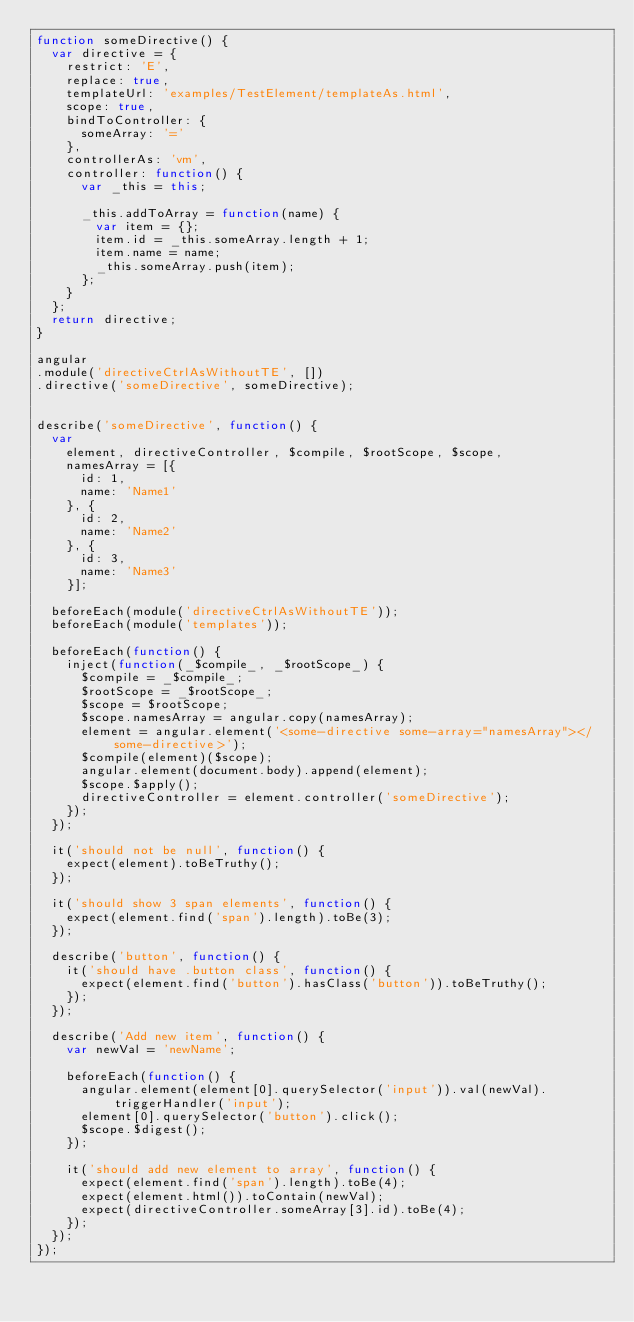Convert code to text. <code><loc_0><loc_0><loc_500><loc_500><_JavaScript_>function someDirective() {
  var directive = {
    restrict: 'E',
    replace: true,
    templateUrl: 'examples/TestElement/templateAs.html',
    scope: true,
    bindToController: {
      someArray: '='
    },
    controllerAs: 'vm',
    controller: function() {
      var _this = this;

      _this.addToArray = function(name) {
        var item = {};
        item.id = _this.someArray.length + 1;
        item.name = name;
        _this.someArray.push(item);
      };
    }
  };
  return directive;
}

angular
.module('directiveCtrlAsWithoutTE', [])
.directive('someDirective', someDirective);


describe('someDirective', function() {
  var
    element, directiveController, $compile, $rootScope, $scope,
    namesArray = [{
      id: 1,
      name: 'Name1'
    }, {
      id: 2,
      name: 'Name2'
    }, {
      id: 3,
      name: 'Name3'
    }];

  beforeEach(module('directiveCtrlAsWithoutTE'));
  beforeEach(module('templates'));

  beforeEach(function() {
    inject(function(_$compile_, _$rootScope_) {
      $compile = _$compile_;
      $rootScope = _$rootScope_;
      $scope = $rootScope;
      $scope.namesArray = angular.copy(namesArray);
      element = angular.element('<some-directive some-array="namesArray"></some-directive>');
      $compile(element)($scope);
      angular.element(document.body).append(element);
      $scope.$apply();
      directiveController = element.controller('someDirective');
    });
  });

  it('should not be null', function() {
    expect(element).toBeTruthy();
  });

  it('should show 3 span elements', function() {
    expect(element.find('span').length).toBe(3);
  });

  describe('button', function() {
    it('should have .button class', function() {
      expect(element.find('button').hasClass('button')).toBeTruthy();
    });
  });

  describe('Add new item', function() {
    var newVal = 'newName';

    beforeEach(function() {
      angular.element(element[0].querySelector('input')).val(newVal).triggerHandler('input');
      element[0].querySelector('button').click();
      $scope.$digest();
    });

    it('should add new element to array', function() {
      expect(element.find('span').length).toBe(4);
      expect(element.html()).toContain(newVal);
      expect(directiveController.someArray[3].id).toBe(4);
    });
  });
});

</code> 